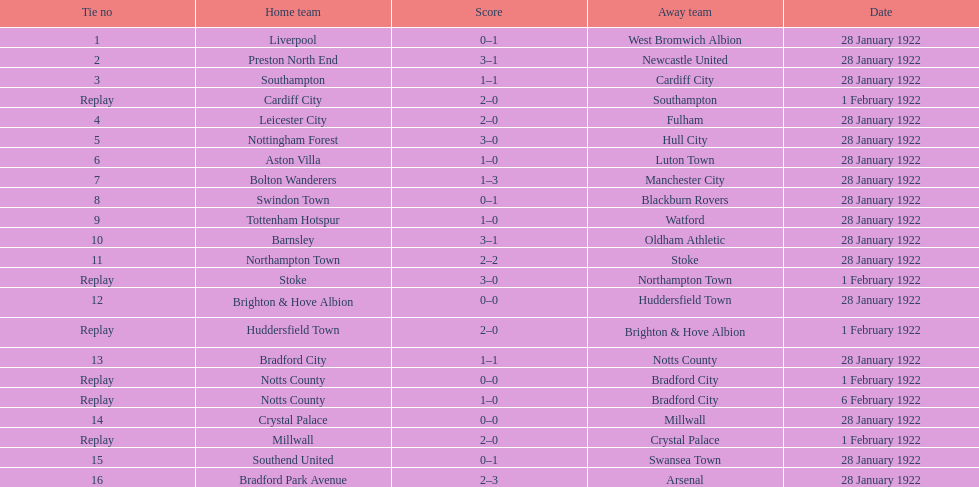In how many games were four or more total points scored? 5. 